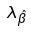<formula> <loc_0><loc_0><loc_500><loc_500>\lambda _ { \hat { \beta } }</formula> 